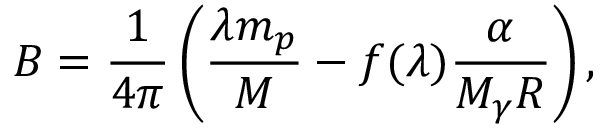<formula> <loc_0><loc_0><loc_500><loc_500>B = \frac { 1 } { 4 \pi } \left ( \frac { \lambda m _ { p } } { M } - f ( \lambda ) \frac { \alpha } { M _ { \gamma } R } \right ) ,</formula> 